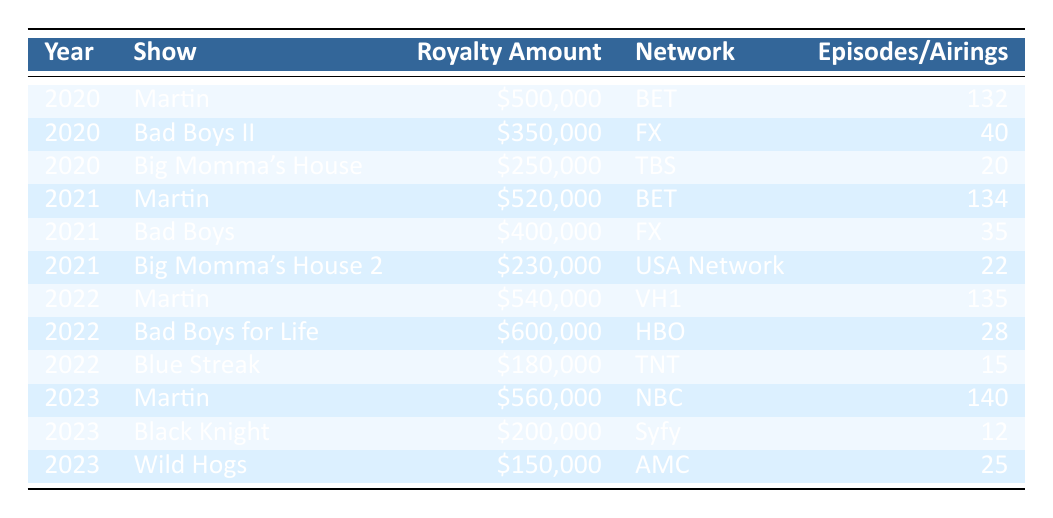What was the highest royalty amount received from a single show in 2022? The shows in 2022 include "Martin" with $540,000, "Bad Boys for Life" with $600,000, and "Blue Streak" with $180,000. The maximum of these amounts is $600,000 from "Bad Boys for Life".
Answer: 600000 How many episodes of "Martin" were syndicated in total from 2020 to 2023? The table has the following syndicated episodes for "Martin": 132 in 2020, 134 in 2021, 135 in 2022, and 140 in 2023. Adding these gives 132 + 134 + 135 + 140 = 541 episodes.
Answer: 541 Did "Big Momma's House 2" receive royalties in 2020? "Big Momma's House 2" is listed for 2021 in the table and does not appear for 2020, which means it did not receive royalties that year.
Answer: No Which show had the lowest total earnings in 2021? In 2021, the royalties were: "Martin" $520,000, "Bad Boys" $400,000, and "Big Momma's House 2" $230,000. The lowest amount is $230,000 from "Big Momma's House 2".
Answer: Big Momma's House 2 What was the average royalty amount for "Martin" from 2020 to 2023? The royalties for "Martin" are: $500,000 (2020), $520,000 (2021), $540,000 (2022), and $560,000 (2023). To find the average, add them: 500,000 + 520,000 + 540,000 + 560,000 = 2,120,000. Then, divide by 4: 2,120,000 / 4 = 530,000.
Answer: 530000 